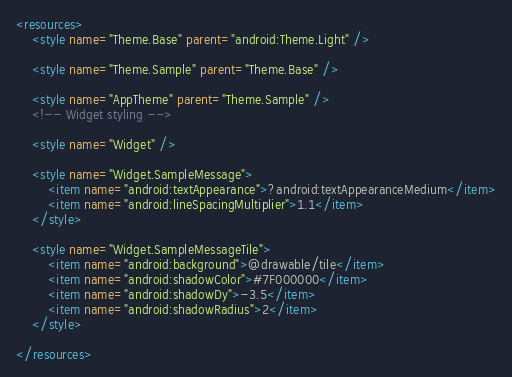Convert code to text. <code><loc_0><loc_0><loc_500><loc_500><_XML_><resources>
    <style name="Theme.Base" parent="android:Theme.Light" />

    <style name="Theme.Sample" parent="Theme.Base" />

    <style name="AppTheme" parent="Theme.Sample" />
    <!-- Widget styling -->

    <style name="Widget" />

    <style name="Widget.SampleMessage">
        <item name="android:textAppearance">?android:textAppearanceMedium</item>
        <item name="android:lineSpacingMultiplier">1.1</item>
    </style>

    <style name="Widget.SampleMessageTile">
        <item name="android:background">@drawable/tile</item>
        <item name="android:shadowColor">#7F000000</item>
        <item name="android:shadowDy">-3.5</item>
        <item name="android:shadowRadius">2</item>
    </style>

</resources>
</code> 